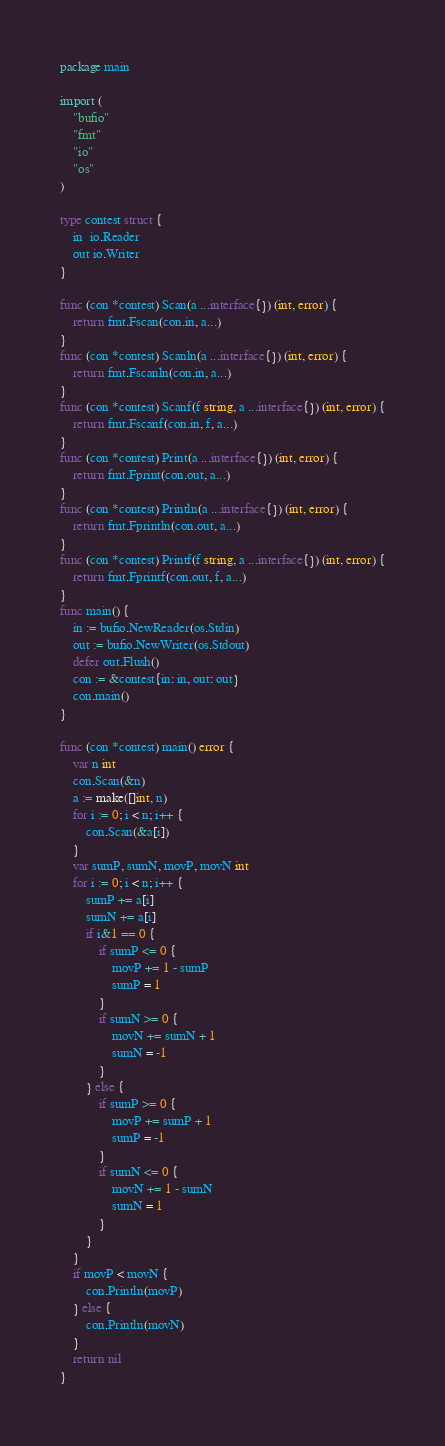<code> <loc_0><loc_0><loc_500><loc_500><_Go_>package main

import (
	"bufio"
	"fmt"
	"io"
	"os"
)

type contest struct {
	in  io.Reader
	out io.Writer
}

func (con *contest) Scan(a ...interface{}) (int, error) {
	return fmt.Fscan(con.in, a...)
}
func (con *contest) Scanln(a ...interface{}) (int, error) {
	return fmt.Fscanln(con.in, a...)
}
func (con *contest) Scanf(f string, a ...interface{}) (int, error) {
	return fmt.Fscanf(con.in, f, a...)
}
func (con *contest) Print(a ...interface{}) (int, error) {
	return fmt.Fprint(con.out, a...)
}
func (con *contest) Println(a ...interface{}) (int, error) {
	return fmt.Fprintln(con.out, a...)
}
func (con *contest) Printf(f string, a ...interface{}) (int, error) {
	return fmt.Fprintf(con.out, f, a...)
}
func main() {
	in := bufio.NewReader(os.Stdin)
	out := bufio.NewWriter(os.Stdout)
	defer out.Flush()
	con := &contest{in: in, out: out}
	con.main()
}

func (con *contest) main() error {
	var n int
	con.Scan(&n)
	a := make([]int, n)
	for i := 0; i < n; i++ {
		con.Scan(&a[i])
	}
	var sumP, sumN, movP, movN int
	for i := 0; i < n; i++ {
		sumP += a[i]
		sumN += a[i]
		if i&1 == 0 {
			if sumP <= 0 {
				movP += 1 - sumP
				sumP = 1
			}
			if sumN >= 0 {
				movN += sumN + 1
				sumN = -1
			}
		} else {
			if sumP >= 0 {
				movP += sumP + 1
				sumP = -1
			}
			if sumN <= 0 {
				movN += 1 - sumN
				sumN = 1
			}
		}
	}
	if movP < movN {
		con.Println(movP)
	} else {
		con.Println(movN)
	}
	return nil
}
</code> 